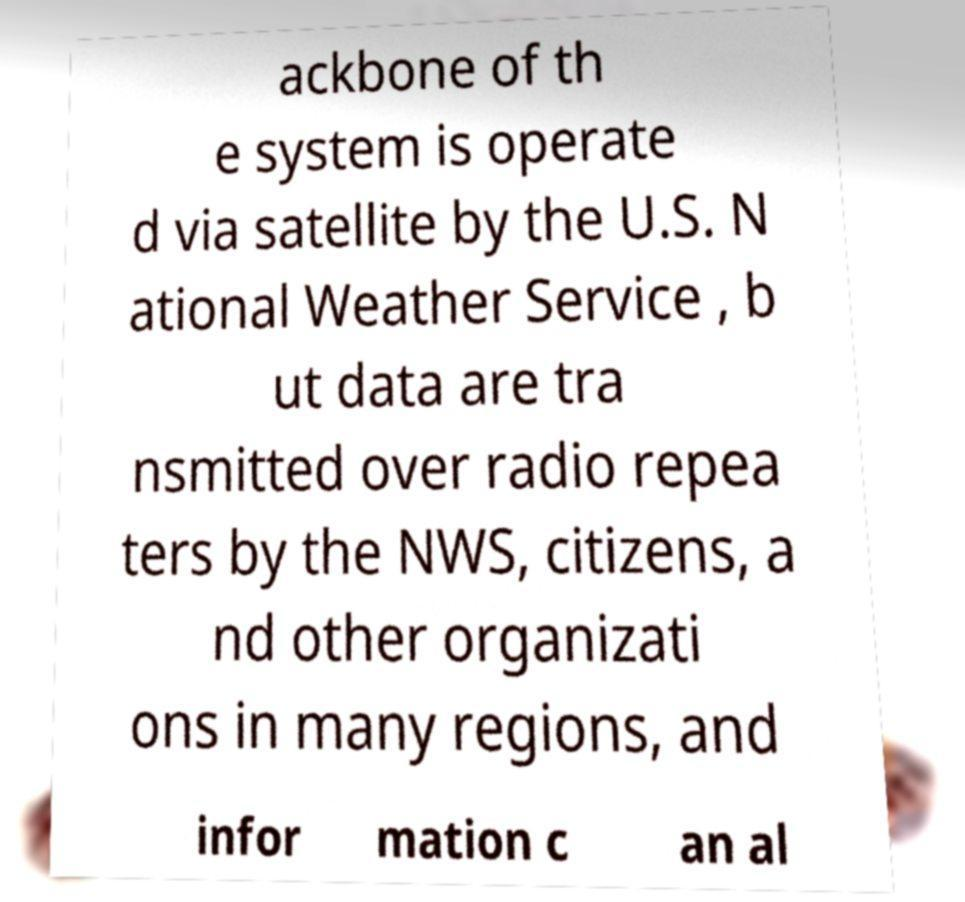What messages or text are displayed in this image? I need them in a readable, typed format. ackbone of th e system is operate d via satellite by the U.S. N ational Weather Service , b ut data are tra nsmitted over radio repea ters by the NWS, citizens, a nd other organizati ons in many regions, and infor mation c an al 